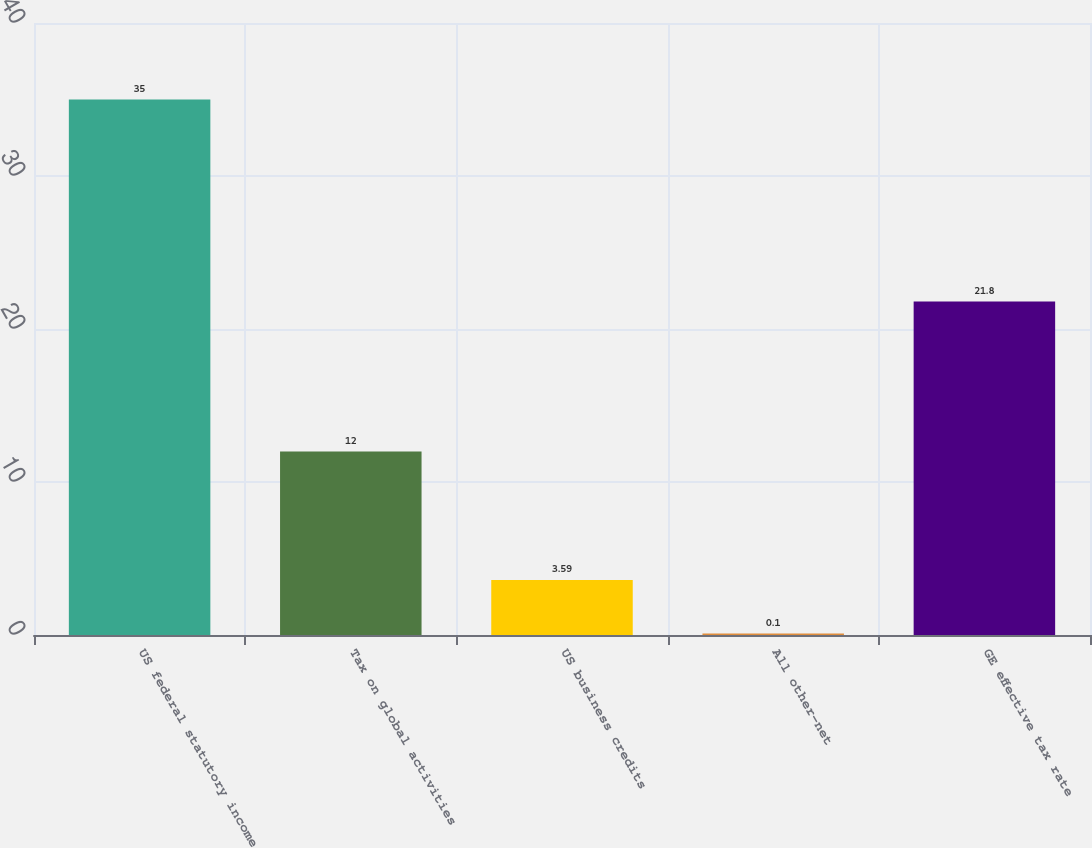Convert chart to OTSL. <chart><loc_0><loc_0><loc_500><loc_500><bar_chart><fcel>US federal statutory income<fcel>Tax on global activities<fcel>US business credits<fcel>All other-net<fcel>GE effective tax rate<nl><fcel>35<fcel>12<fcel>3.59<fcel>0.1<fcel>21.8<nl></chart> 